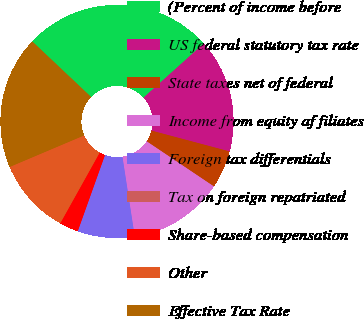Convert chart to OTSL. <chart><loc_0><loc_0><loc_500><loc_500><pie_chart><fcel>(Percent of income before<fcel>US federal statutory tax rate<fcel>State taxes net of federal<fcel>Income from equity af filiates<fcel>Foreign tax differentials<fcel>Tax on foreign repatriated<fcel>Share-based compensation<fcel>Other<fcel>Effective Tax Rate<nl><fcel>26.31%<fcel>15.79%<fcel>5.26%<fcel>13.16%<fcel>7.9%<fcel>0.0%<fcel>2.63%<fcel>10.53%<fcel>18.42%<nl></chart> 